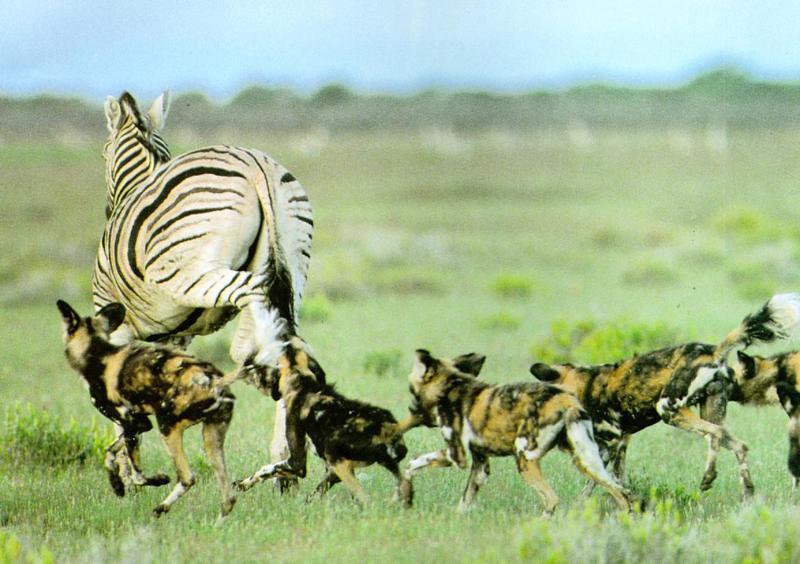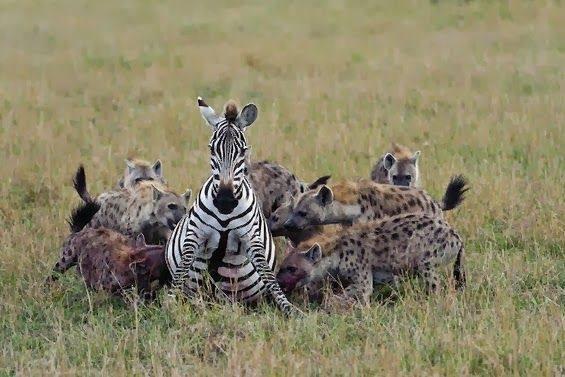The first image is the image on the left, the second image is the image on the right. Evaluate the accuracy of this statement regarding the images: "There are three hyenas in the left image.". Is it true? Answer yes or no. No. The first image is the image on the left, the second image is the image on the right. Assess this claim about the two images: "The lefthand image includes a predator-type non-hooved animal besides a hyena.". Correct or not? Answer yes or no. No. 